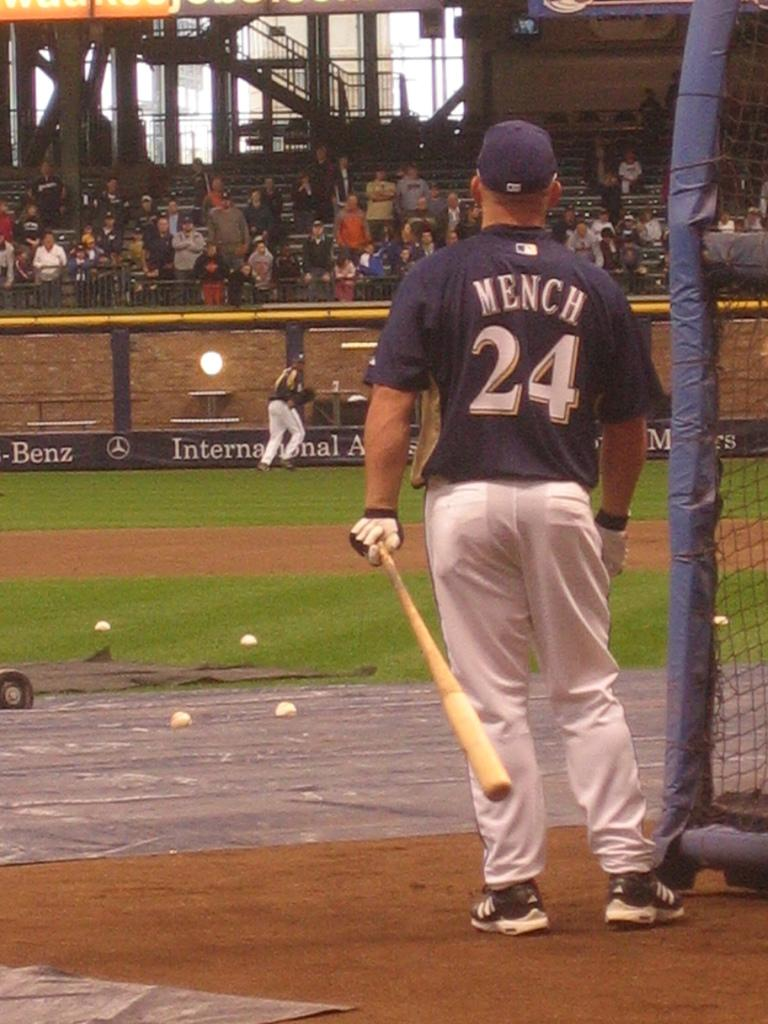Provide a one-sentence caption for the provided image. A baseball player standing at a batting cage, with the name Mench on the uniform. 